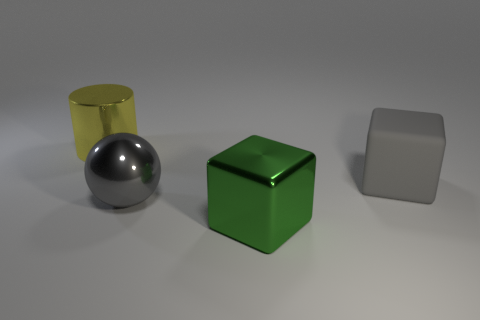Add 4 big yellow metal cylinders. How many objects exist? 8 Subtract all balls. How many objects are left? 3 Add 3 large rubber objects. How many large rubber objects exist? 4 Subtract 0 yellow blocks. How many objects are left? 4 Subtract all large balls. Subtract all tiny rubber balls. How many objects are left? 3 Add 2 metal cylinders. How many metal cylinders are left? 3 